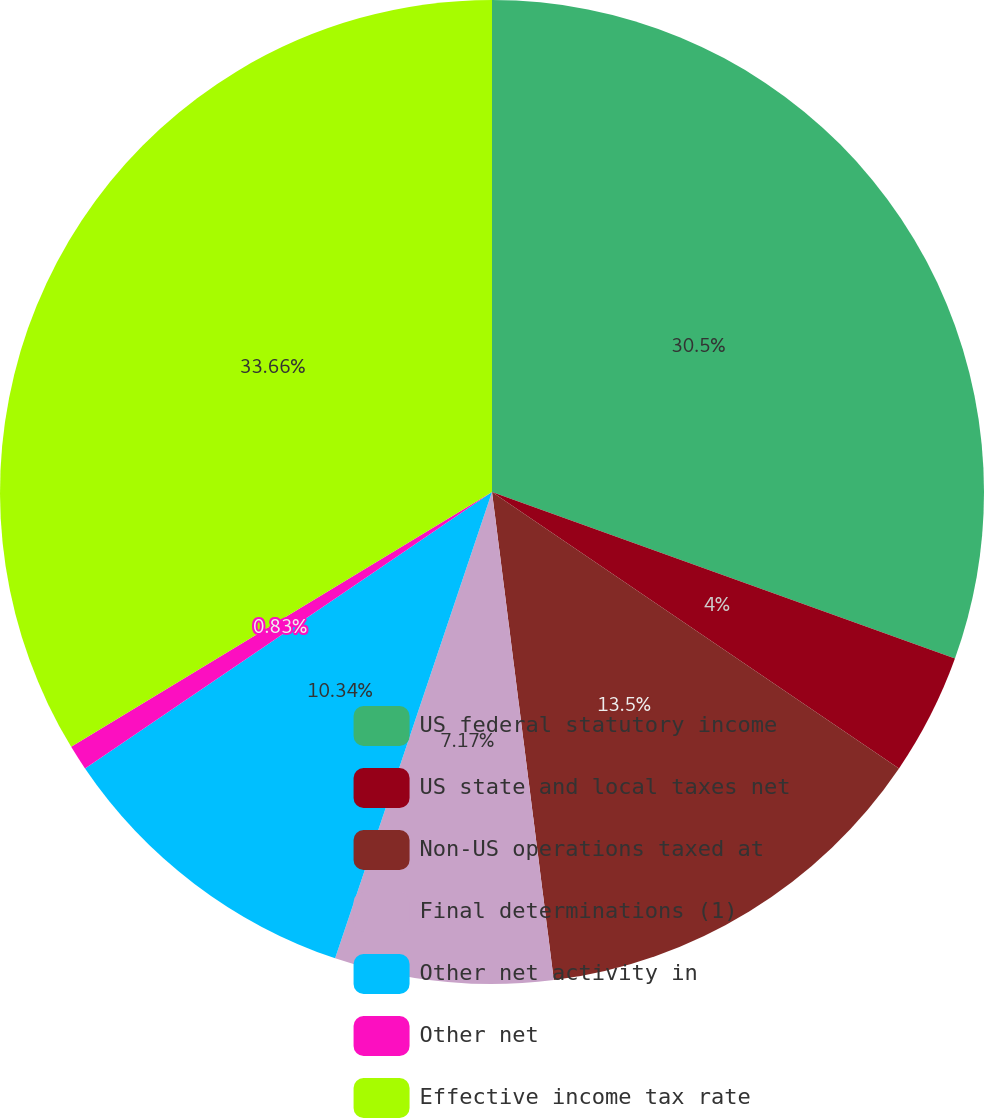Convert chart. <chart><loc_0><loc_0><loc_500><loc_500><pie_chart><fcel>US federal statutory income<fcel>US state and local taxes net<fcel>Non-US operations taxed at<fcel>Final determinations (1)<fcel>Other net activity in<fcel>Other net<fcel>Effective income tax rate<nl><fcel>30.5%<fcel>4.0%<fcel>13.5%<fcel>7.17%<fcel>10.34%<fcel>0.83%<fcel>33.67%<nl></chart> 